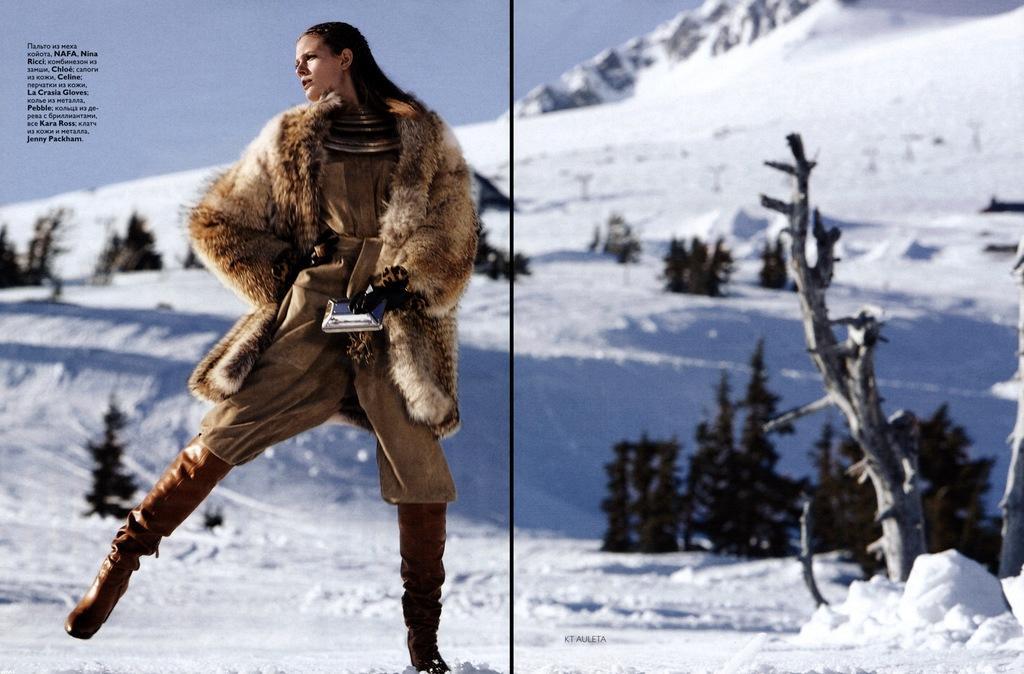Can you describe this image briefly? In this picture I see a woman in front who is standing and I see that she is wearing a dress which is of brown in color and I see that there is something written on the left top of this image and in the background I see the ground covered with snow and I see number of trees. 